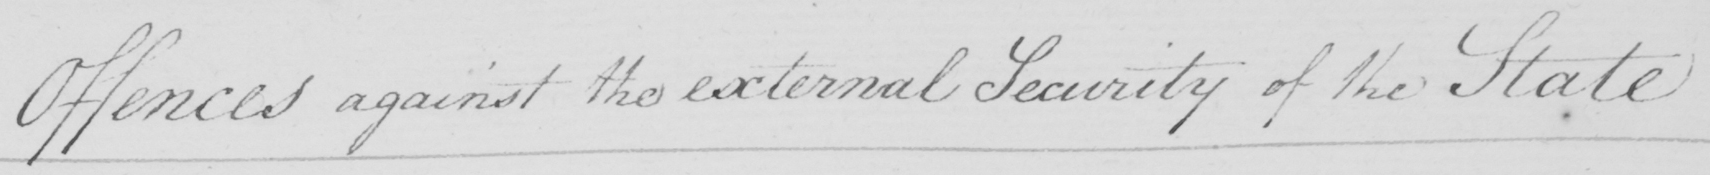What is written in this line of handwriting? Offences against the external Security of the State. 